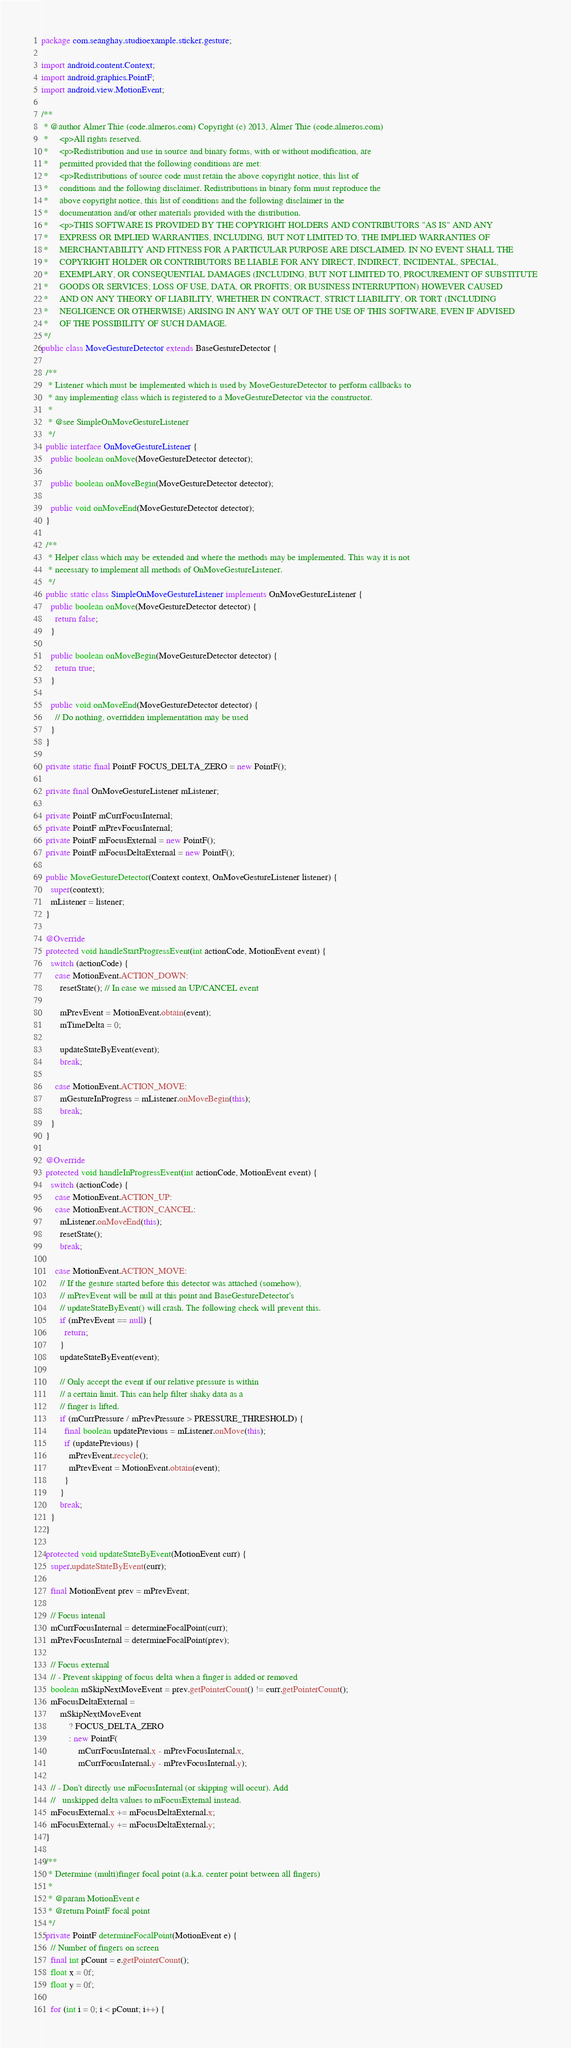Convert code to text. <code><loc_0><loc_0><loc_500><loc_500><_Java_>package com.seanghay.studioexample.sticker.gesture;

import android.content.Context;
import android.graphics.PointF;
import android.view.MotionEvent;

/**
 * @author Almer Thie (code.almeros.com) Copyright (c) 2013, Almer Thie (code.almeros.com)
 *     <p>All rights reserved.
 *     <p>Redistribution and use in source and binary forms, with or without modification, are
 *     permitted provided that the following conditions are met:
 *     <p>Redistributions of source code must retain the above copyright notice, this list of
 *     conditions and the following disclaimer. Redistributions in binary form must reproduce the
 *     above copyright notice, this list of conditions and the following disclaimer in the
 *     documentation and/or other materials provided with the distribution.
 *     <p>THIS SOFTWARE IS PROVIDED BY THE COPYRIGHT HOLDERS AND CONTRIBUTORS "AS IS" AND ANY
 *     EXPRESS OR IMPLIED WARRANTIES, INCLUDING, BUT NOT LIMITED TO, THE IMPLIED WARRANTIES OF
 *     MERCHANTABILITY AND FITNESS FOR A PARTICULAR PURPOSE ARE DISCLAIMED. IN NO EVENT SHALL THE
 *     COPYRIGHT HOLDER OR CONTRIBUTORS BE LIABLE FOR ANY DIRECT, INDIRECT, INCIDENTAL, SPECIAL,
 *     EXEMPLARY, OR CONSEQUENTIAL DAMAGES (INCLUDING, BUT NOT LIMITED TO, PROCUREMENT OF SUBSTITUTE
 *     GOODS OR SERVICES; LOSS OF USE, DATA, OR PROFITS; OR BUSINESS INTERRUPTION) HOWEVER CAUSED
 *     AND ON ANY THEORY OF LIABILITY, WHETHER IN CONTRACT, STRICT LIABILITY, OR TORT (INCLUDING
 *     NEGLIGENCE OR OTHERWISE) ARISING IN ANY WAY OUT OF THE USE OF THIS SOFTWARE, EVEN IF ADVISED
 *     OF THE POSSIBILITY OF SUCH DAMAGE.
 */
public class MoveGestureDetector extends BaseGestureDetector {

  /**
   * Listener which must be implemented which is used by MoveGestureDetector to perform callbacks to
   * any implementing class which is registered to a MoveGestureDetector via the constructor.
   *
   * @see SimpleOnMoveGestureListener
   */
  public interface OnMoveGestureListener {
    public boolean onMove(MoveGestureDetector detector);

    public boolean onMoveBegin(MoveGestureDetector detector);

    public void onMoveEnd(MoveGestureDetector detector);
  }

  /**
   * Helper class which may be extended and where the methods may be implemented. This way it is not
   * necessary to implement all methods of OnMoveGestureListener.
   */
  public static class SimpleOnMoveGestureListener implements OnMoveGestureListener {
    public boolean onMove(MoveGestureDetector detector) {
      return false;
    }

    public boolean onMoveBegin(MoveGestureDetector detector) {
      return true;
    }

    public void onMoveEnd(MoveGestureDetector detector) {
      // Do nothing, overridden implementation may be used
    }
  }

  private static final PointF FOCUS_DELTA_ZERO = new PointF();

  private final OnMoveGestureListener mListener;

  private PointF mCurrFocusInternal;
  private PointF mPrevFocusInternal;
  private PointF mFocusExternal = new PointF();
  private PointF mFocusDeltaExternal = new PointF();

  public MoveGestureDetector(Context context, OnMoveGestureListener listener) {
    super(context);
    mListener = listener;
  }

  @Override
  protected void handleStartProgressEvent(int actionCode, MotionEvent event) {
    switch (actionCode) {
      case MotionEvent.ACTION_DOWN:
        resetState(); // In case we missed an UP/CANCEL event

        mPrevEvent = MotionEvent.obtain(event);
        mTimeDelta = 0;

        updateStateByEvent(event);
        break;

      case MotionEvent.ACTION_MOVE:
        mGestureInProgress = mListener.onMoveBegin(this);
        break;
    }
  }

  @Override
  protected void handleInProgressEvent(int actionCode, MotionEvent event) {
    switch (actionCode) {
      case MotionEvent.ACTION_UP:
      case MotionEvent.ACTION_CANCEL:
        mListener.onMoveEnd(this);
        resetState();
        break;

      case MotionEvent.ACTION_MOVE:
        // If the gesture started before this detector was attached (somehow),
        // mPrevEvent will be null at this point and BaseGestureDetector's
        // updateStateByEvent() will crash. The following check will prevent this.
        if (mPrevEvent == null) {
          return;
        }
        updateStateByEvent(event);

        // Only accept the event if our relative pressure is within
        // a certain limit. This can help filter shaky data as a
        // finger is lifted.
        if (mCurrPressure / mPrevPressure > PRESSURE_THRESHOLD) {
          final boolean updatePrevious = mListener.onMove(this);
          if (updatePrevious) {
            mPrevEvent.recycle();
            mPrevEvent = MotionEvent.obtain(event);
          }
        }
        break;
    }
  }

  protected void updateStateByEvent(MotionEvent curr) {
    super.updateStateByEvent(curr);

    final MotionEvent prev = mPrevEvent;

    // Focus intenal
    mCurrFocusInternal = determineFocalPoint(curr);
    mPrevFocusInternal = determineFocalPoint(prev);

    // Focus external
    // - Prevent skipping of focus delta when a finger is added or removed
    boolean mSkipNextMoveEvent = prev.getPointerCount() != curr.getPointerCount();
    mFocusDeltaExternal =
        mSkipNextMoveEvent
            ? FOCUS_DELTA_ZERO
            : new PointF(
                mCurrFocusInternal.x - mPrevFocusInternal.x,
                mCurrFocusInternal.y - mPrevFocusInternal.y);

    // - Don't directly use mFocusInternal (or skipping will occur). Add
    // 	 unskipped delta values to mFocusExternal instead.
    mFocusExternal.x += mFocusDeltaExternal.x;
    mFocusExternal.y += mFocusDeltaExternal.y;
  }

  /**
   * Determine (multi)finger focal point (a.k.a. center point between all fingers)
   *
   * @param MotionEvent e
   * @return PointF focal point
   */
  private PointF determineFocalPoint(MotionEvent e) {
    // Number of fingers on screen
    final int pCount = e.getPointerCount();
    float x = 0f;
    float y = 0f;

    for (int i = 0; i < pCount; i++) {</code> 